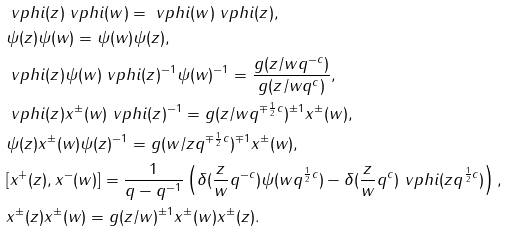<formula> <loc_0><loc_0><loc_500><loc_500>& \ v p h i ( z ) \ v p h i ( w ) = \ v p h i ( w ) \ v p h i ( z ) , \\ & \psi ( z ) \psi ( w ) = \psi ( w ) \psi ( z ) , \\ & \ v p h i ( z ) \psi ( w ) \ v p h i ( z ) ^ { - 1 } \psi ( w ) ^ { - 1 } = \frac { g ( z / w q ^ { - c } ) } { g ( z / w q ^ { c } ) } , \\ & \ v p h i ( z ) x ^ { \pm } ( w ) \ v p h i ( z ) ^ { - 1 } = g ( z / w q ^ { \mp \frac { 1 } { 2 } c } ) ^ { \pm 1 } x ^ { \pm } ( w ) , \\ & \psi ( z ) x ^ { \pm } ( w ) \psi ( z ) ^ { - 1 } = g ( w / z q ^ { \mp \frac { 1 } { 2 } c } ) ^ { \mp 1 } x ^ { \pm } ( w ) , \\ & [ x ^ { + } ( z ) , x ^ { - } ( w ) ] = \frac { 1 } { q - q ^ { - 1 } } \left ( \delta ( \frac { z } { w } q ^ { - c } ) \psi ( w q ^ { \frac { 1 } { 2 } c } ) - \delta ( \frac { z } { w } q ^ { c } ) \ v p h i ( z q ^ { \frac { 1 } { 2 } c } ) \right ) , \\ & x ^ { \pm } ( z ) x ^ { \pm } ( w ) = g ( z / w ) ^ { \pm 1 } x ^ { \pm } ( w ) x ^ { \pm } ( z ) .</formula> 